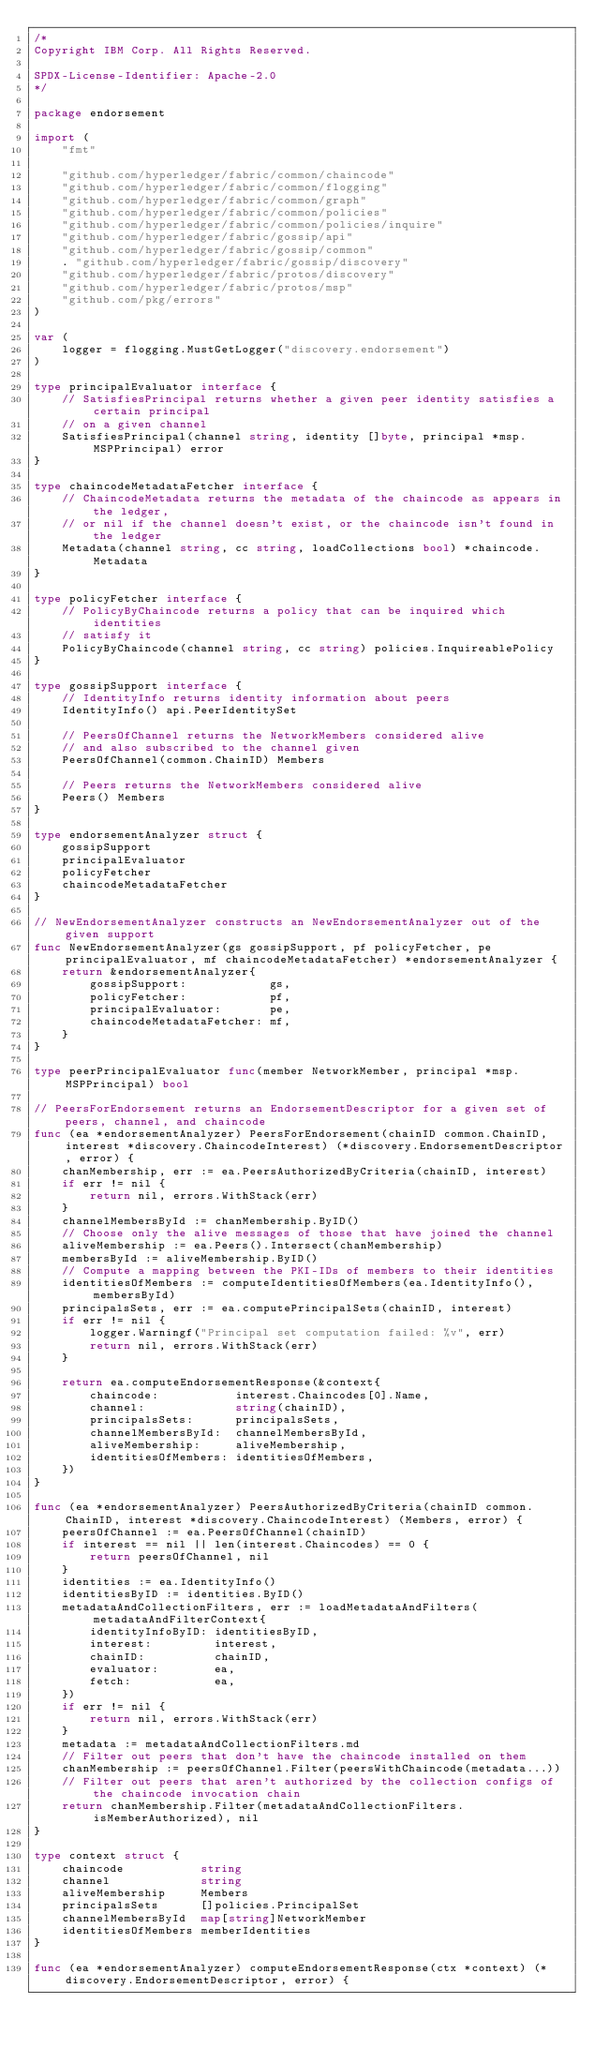<code> <loc_0><loc_0><loc_500><loc_500><_Go_>/*
Copyright IBM Corp. All Rights Reserved.

SPDX-License-Identifier: Apache-2.0
*/

package endorsement

import (
	"fmt"

	"github.com/hyperledger/fabric/common/chaincode"
	"github.com/hyperledger/fabric/common/flogging"
	"github.com/hyperledger/fabric/common/graph"
	"github.com/hyperledger/fabric/common/policies"
	"github.com/hyperledger/fabric/common/policies/inquire"
	"github.com/hyperledger/fabric/gossip/api"
	"github.com/hyperledger/fabric/gossip/common"
	. "github.com/hyperledger/fabric/gossip/discovery"
	"github.com/hyperledger/fabric/protos/discovery"
	"github.com/hyperledger/fabric/protos/msp"
	"github.com/pkg/errors"
)

var (
	logger = flogging.MustGetLogger("discovery.endorsement")
)

type principalEvaluator interface {
	// SatisfiesPrincipal returns whether a given peer identity satisfies a certain principal
	// on a given channel
	SatisfiesPrincipal(channel string, identity []byte, principal *msp.MSPPrincipal) error
}

type chaincodeMetadataFetcher interface {
	// ChaincodeMetadata returns the metadata of the chaincode as appears in the ledger,
	// or nil if the channel doesn't exist, or the chaincode isn't found in the ledger
	Metadata(channel string, cc string, loadCollections bool) *chaincode.Metadata
}

type policyFetcher interface {
	// PolicyByChaincode returns a policy that can be inquired which identities
	// satisfy it
	PolicyByChaincode(channel string, cc string) policies.InquireablePolicy
}

type gossipSupport interface {
	// IdentityInfo returns identity information about peers
	IdentityInfo() api.PeerIdentitySet

	// PeersOfChannel returns the NetworkMembers considered alive
	// and also subscribed to the channel given
	PeersOfChannel(common.ChainID) Members

	// Peers returns the NetworkMembers considered alive
	Peers() Members
}

type endorsementAnalyzer struct {
	gossipSupport
	principalEvaluator
	policyFetcher
	chaincodeMetadataFetcher
}

// NewEndorsementAnalyzer constructs an NewEndorsementAnalyzer out of the given support
func NewEndorsementAnalyzer(gs gossipSupport, pf policyFetcher, pe principalEvaluator, mf chaincodeMetadataFetcher) *endorsementAnalyzer {
	return &endorsementAnalyzer{
		gossipSupport:            gs,
		policyFetcher:            pf,
		principalEvaluator:       pe,
		chaincodeMetadataFetcher: mf,
	}
}

type peerPrincipalEvaluator func(member NetworkMember, principal *msp.MSPPrincipal) bool

// PeersForEndorsement returns an EndorsementDescriptor for a given set of peers, channel, and chaincode
func (ea *endorsementAnalyzer) PeersForEndorsement(chainID common.ChainID, interest *discovery.ChaincodeInterest) (*discovery.EndorsementDescriptor, error) {
	chanMembership, err := ea.PeersAuthorizedByCriteria(chainID, interest)
	if err != nil {
		return nil, errors.WithStack(err)
	}
	channelMembersById := chanMembership.ByID()
	// Choose only the alive messages of those that have joined the channel
	aliveMembership := ea.Peers().Intersect(chanMembership)
	membersById := aliveMembership.ByID()
	// Compute a mapping between the PKI-IDs of members to their identities
	identitiesOfMembers := computeIdentitiesOfMembers(ea.IdentityInfo(), membersById)
	principalsSets, err := ea.computePrincipalSets(chainID, interest)
	if err != nil {
		logger.Warningf("Principal set computation failed: %v", err)
		return nil, errors.WithStack(err)
	}

	return ea.computeEndorsementResponse(&context{
		chaincode:           interest.Chaincodes[0].Name,
		channel:             string(chainID),
		principalsSets:      principalsSets,
		channelMembersById:  channelMembersById,
		aliveMembership:     aliveMembership,
		identitiesOfMembers: identitiesOfMembers,
	})
}

func (ea *endorsementAnalyzer) PeersAuthorizedByCriteria(chainID common.ChainID, interest *discovery.ChaincodeInterest) (Members, error) {
	peersOfChannel := ea.PeersOfChannel(chainID)
	if interest == nil || len(interest.Chaincodes) == 0 {
		return peersOfChannel, nil
	}
	identities := ea.IdentityInfo()
	identitiesByID := identities.ByID()
	metadataAndCollectionFilters, err := loadMetadataAndFilters(metadataAndFilterContext{
		identityInfoByID: identitiesByID,
		interest:         interest,
		chainID:          chainID,
		evaluator:        ea,
		fetch:            ea,
	})
	if err != nil {
		return nil, errors.WithStack(err)
	}
	metadata := metadataAndCollectionFilters.md
	// Filter out peers that don't have the chaincode installed on them
	chanMembership := peersOfChannel.Filter(peersWithChaincode(metadata...))
	// Filter out peers that aren't authorized by the collection configs of the chaincode invocation chain
	return chanMembership.Filter(metadataAndCollectionFilters.isMemberAuthorized), nil
}

type context struct {
	chaincode           string
	channel             string
	aliveMembership     Members
	principalsSets      []policies.PrincipalSet
	channelMembersById  map[string]NetworkMember
	identitiesOfMembers memberIdentities
}

func (ea *endorsementAnalyzer) computeEndorsementResponse(ctx *context) (*discovery.EndorsementDescriptor, error) {</code> 